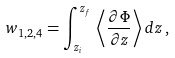Convert formula to latex. <formula><loc_0><loc_0><loc_500><loc_500>w _ { 1 , 2 , 4 } = \int _ { z _ { i } } ^ { z _ { f } } \, \left \langle \frac { \partial \Phi } { \partial z } \right \rangle d z \, ,</formula> 